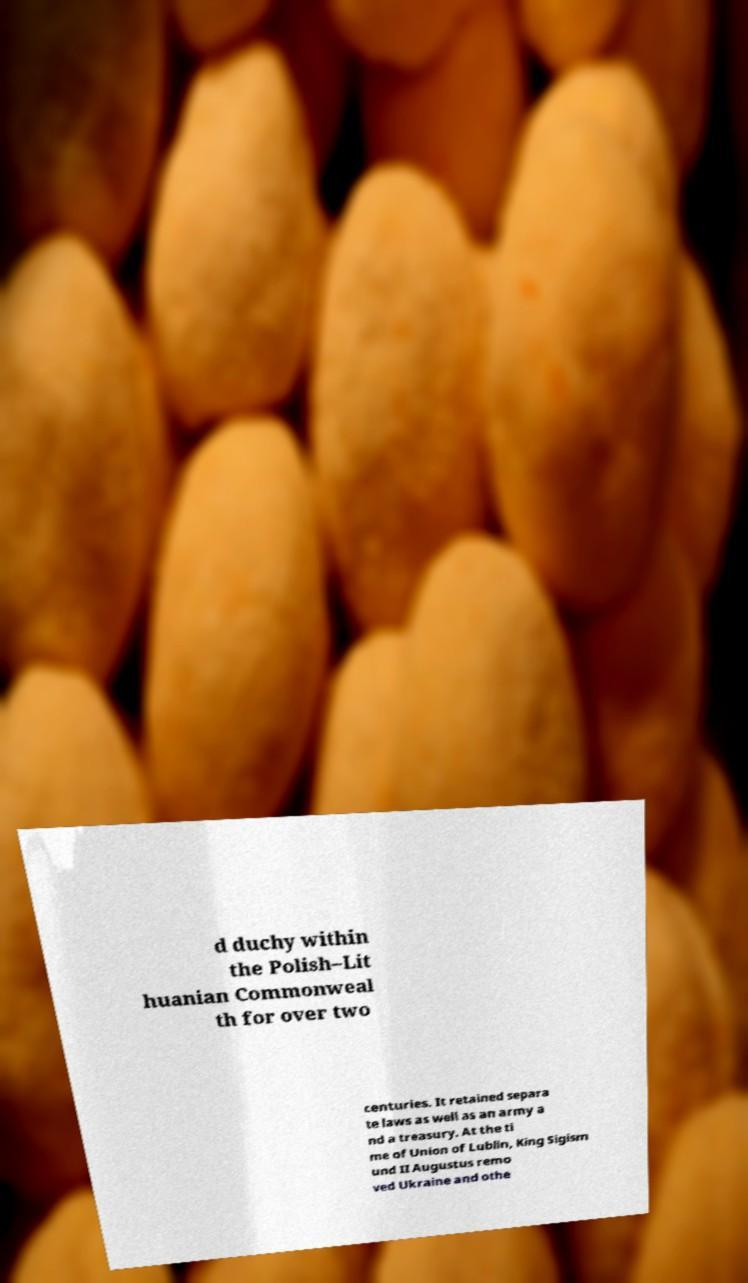For documentation purposes, I need the text within this image transcribed. Could you provide that? d duchy within the Polish–Lit huanian Commonweal th for over two centuries. It retained separa te laws as well as an army a nd a treasury. At the ti me of Union of Lublin, King Sigism und II Augustus remo ved Ukraine and othe 